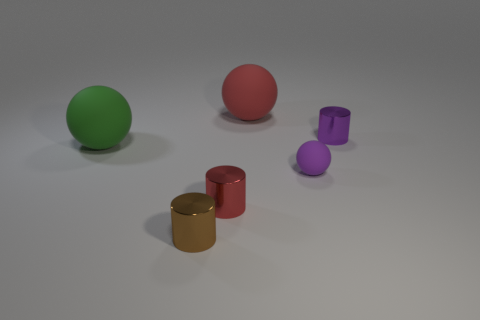Subtract all large spheres. How many spheres are left? 1 Subtract 1 cylinders. How many cylinders are left? 2 Add 3 big cyan shiny cylinders. How many objects exist? 9 Subtract all purple shiny cylinders. Subtract all tiny purple things. How many objects are left? 3 Add 5 tiny red metallic cylinders. How many tiny red metallic cylinders are left? 6 Add 3 cylinders. How many cylinders exist? 6 Subtract 1 purple balls. How many objects are left? 5 Subtract all cyan spheres. Subtract all brown cylinders. How many spheres are left? 3 